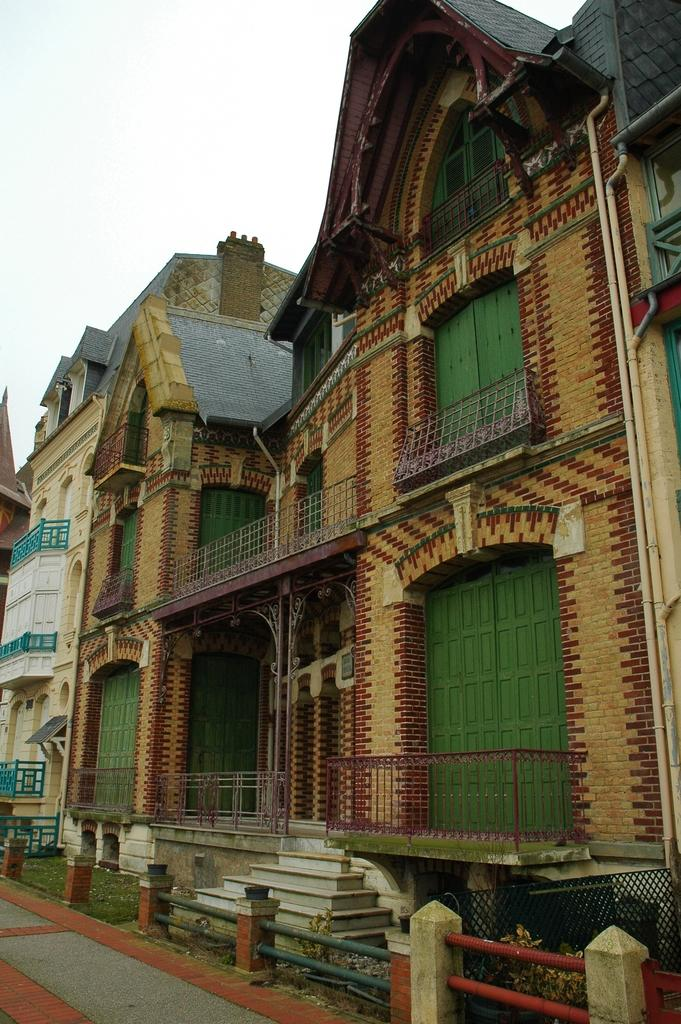What type of view is shown in the image? The image is an outside view. What structures can be seen in the image? There are buildings visible in the image. Where is the road located in the image? A: The road is in the bottom left corner of the image. What is visible at the top of the image? The sky is visible at the top of the image. How many pizzas are being held by the tongue in the image? There are no pizzas or tongues present in the image. What color is the balloon floating above the buildings in the image? There is no balloon present in the image; only buildings, a road, and the sky are visible. 